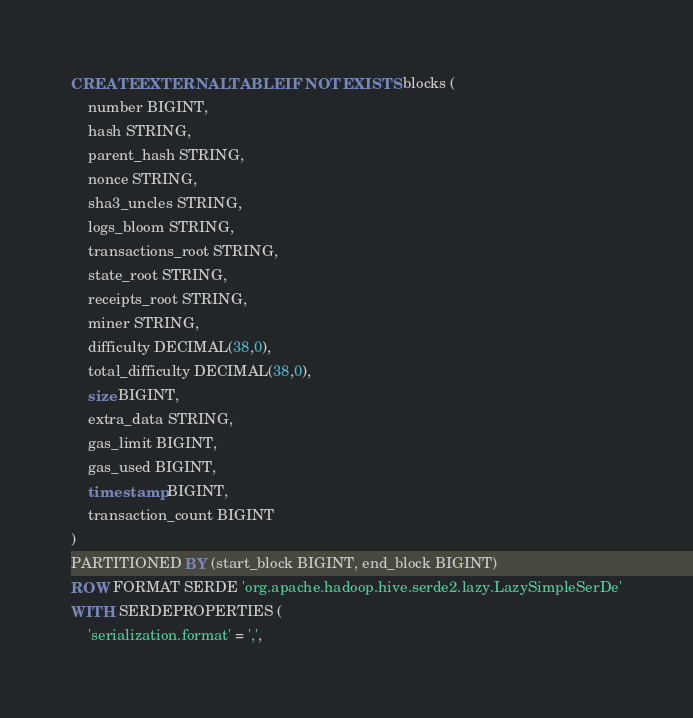<code> <loc_0><loc_0><loc_500><loc_500><_SQL_>CREATE EXTERNAL TABLE IF NOT EXISTS blocks (
    number BIGINT,
    hash STRING,
    parent_hash STRING,
    nonce STRING,
    sha3_uncles STRING,
    logs_bloom STRING,
    transactions_root STRING,
    state_root STRING,
    receipts_root STRING,
    miner STRING,
    difficulty DECIMAL(38,0),
    total_difficulty DECIMAL(38,0),
    size BIGINT,
    extra_data STRING,
    gas_limit BIGINT,
    gas_used BIGINT,
    timestamp BIGINT,
    transaction_count BIGINT
)
PARTITIONED BY (start_block BIGINT, end_block BIGINT)
ROW FORMAT SERDE 'org.apache.hadoop.hive.serde2.lazy.LazySimpleSerDe'
WITH SERDEPROPERTIES (
    'serialization.format' = ',',</code> 